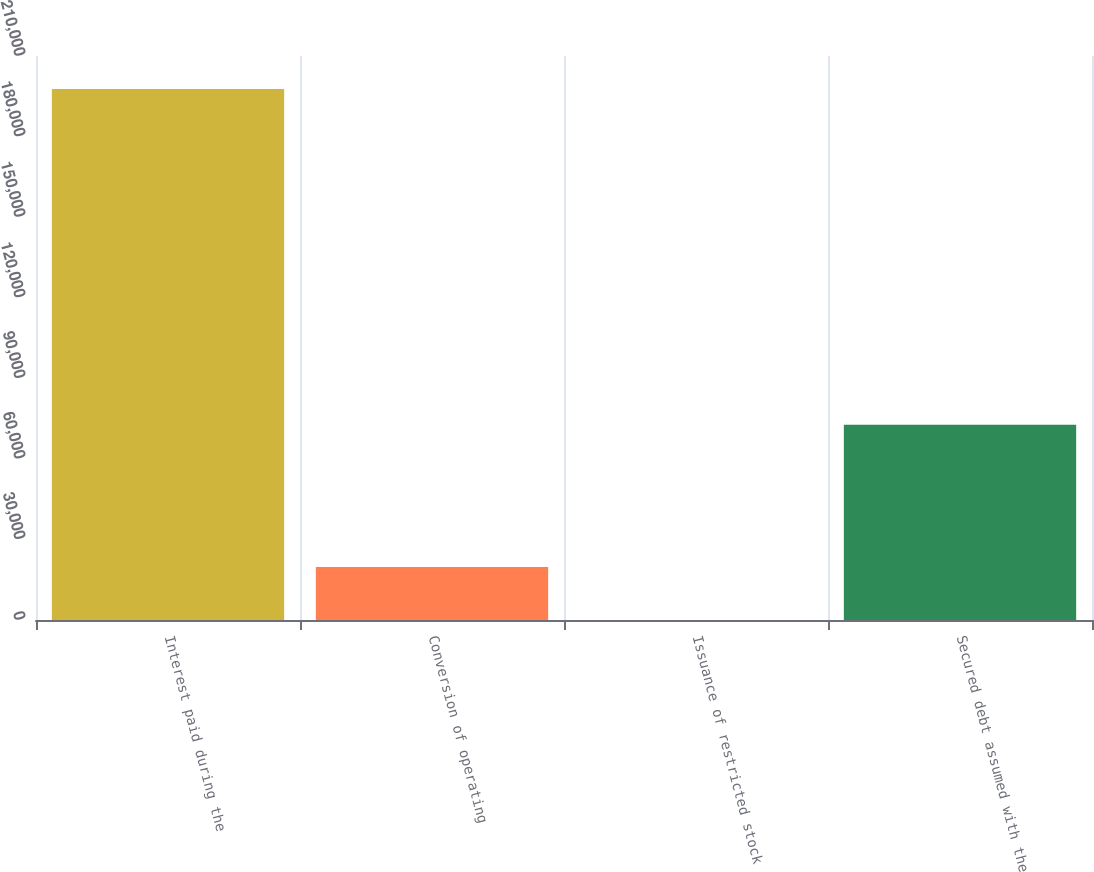Convert chart. <chart><loc_0><loc_0><loc_500><loc_500><bar_chart><fcel>Interest paid during the<fcel>Conversion of operating<fcel>Issuance of restricted stock<fcel>Secured debt assumed with the<nl><fcel>197722<fcel>19773.1<fcel>1<fcel>72680<nl></chart> 